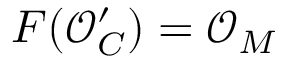<formula> <loc_0><loc_0><loc_500><loc_500>F ( { \mathcal { O } } _ { C } ^ { \prime } ) = { \mathcal { O } } _ { M }</formula> 